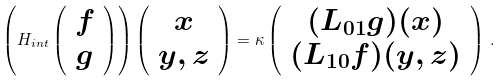<formula> <loc_0><loc_0><loc_500><loc_500>\left ( H _ { i n t } \left ( \begin{array} { c } f \\ g \end{array} \right ) \right ) \left ( \begin{array} { c } x \\ y , z \end{array} \right ) = \kappa \left ( \begin{array} { c } ( L _ { 0 1 } g ) ( x ) \\ ( L _ { 1 0 } f ) ( y , z ) \end{array} \right ) \, .</formula> 